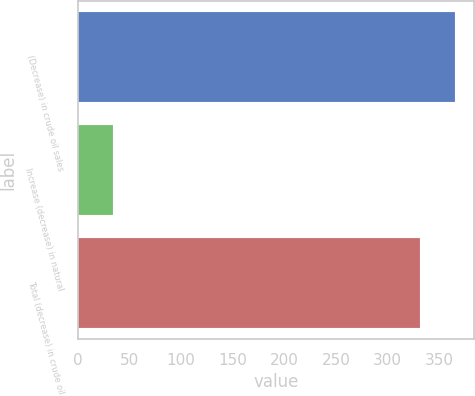<chart> <loc_0><loc_0><loc_500><loc_500><bar_chart><fcel>(Decrease) in crude oil sales<fcel>Increase (decrease) in natural<fcel>Total (decrease) in crude oil<nl><fcel>365<fcel>34<fcel>331<nl></chart> 